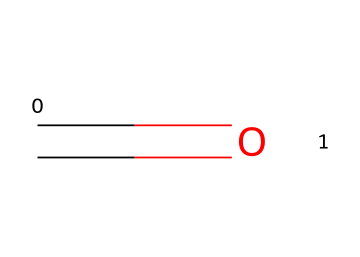What is the functional group present in this chemical? The chemical structure shows a carbon atom double-bonded to an oxygen atom (C=O), which indicates the presence of a carbonyl functional group, specifically characteristic of aldehydes as they have the carbonyl group at the terminal position of a carbon chain.
Answer: carbonyl How many hydrogen atoms are attached to the carbonyl carbon? In the aldehyde structure, the carbon atom is double-bonded to an oxygen atom and also single-bonded to one hydrogen atom. Therefore, there is one hydrogen atom attached to the carbonyl carbon.
Answer: one What is the general formula for aldehydes? Aldehydes generally follow the structure R-CHO, where R can be a hydrogen or a carbon-containing group. Considering the structural representation, the simplest aldehyde (formaldehyde) has the formula CH₂O. Hence the general formula is based on this form.
Answer: CH₂O Is this chemical a saturated compound? Evaluating the structure, formaldehyde contains a double bond (C=O) and shows no single bonds to multiple carbon atoms. Because double bonds introduce unsaturation in carbon chains, this structure would not be categorized as saturated.
Answer: no What type of chemical reaction can formaldehyde undergo to produce alcohol? Formaldehyde can undergo nucleophilic addition reactions where a hydride ion adds to the carbonyl carbon. This process ultimately reduces the compound to yield an alcohol.
Answer: reduction 